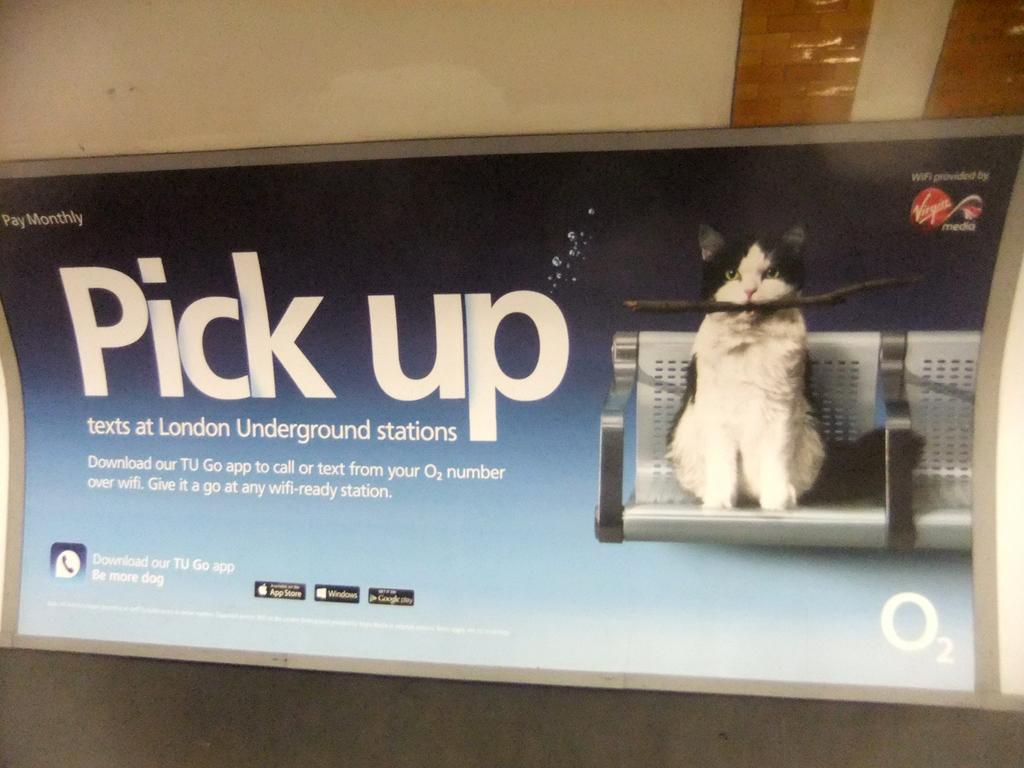Describe this image in one or two sentences. In this image we can see a cat sitting on a chair and it is holding a wooden piece in the mouth. 